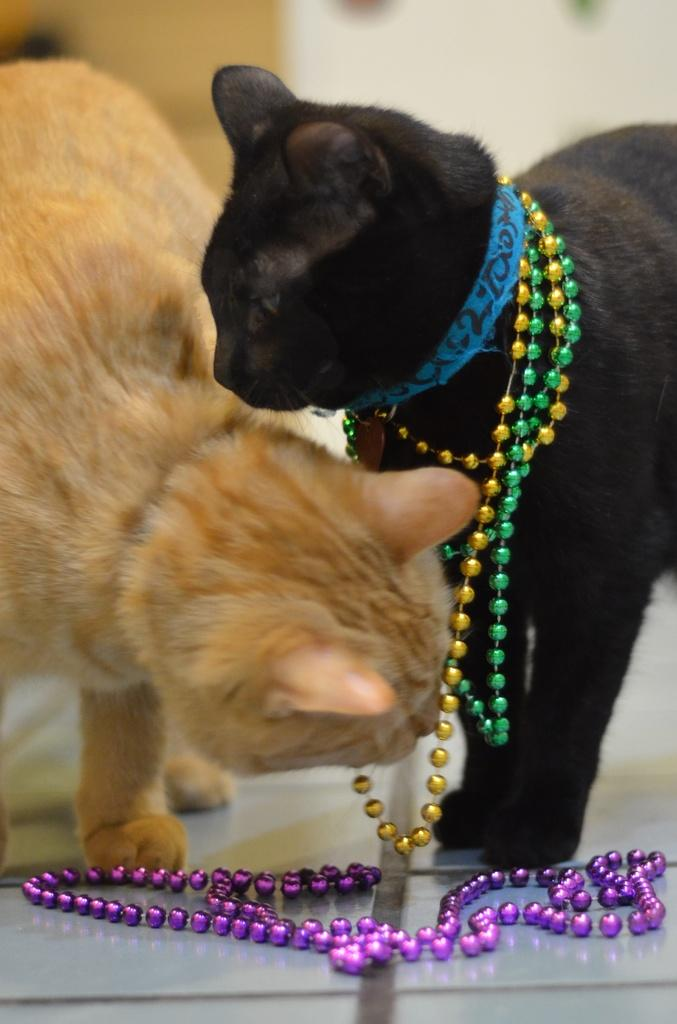What type of animals are present in the image? There are cats in the image. Where are the cats located in the image? The cats are on the floor. How many toes can be seen on the beast in the image? There is no beast present in the image, only cats. Additionally, cats do not have toes on their bodies; they have them on their paws. 